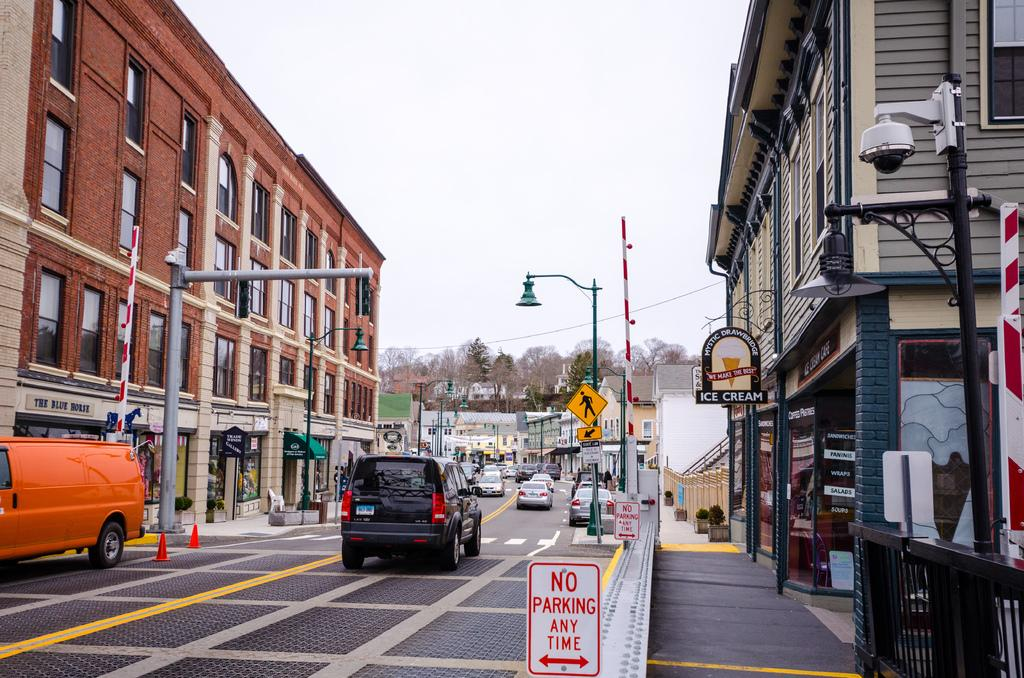What can be seen on the road in the image? There are vehicles on the road in the image. What else is visible in the image besides the vehicles? There are buildings and sign boards visible in the image. Can you see a giraffe walking on the road in the image? No, there is no giraffe present in the image. What type of ear is visible on the vehicles in the image? Vehicles do not have ears; the question is not applicable to the image. 